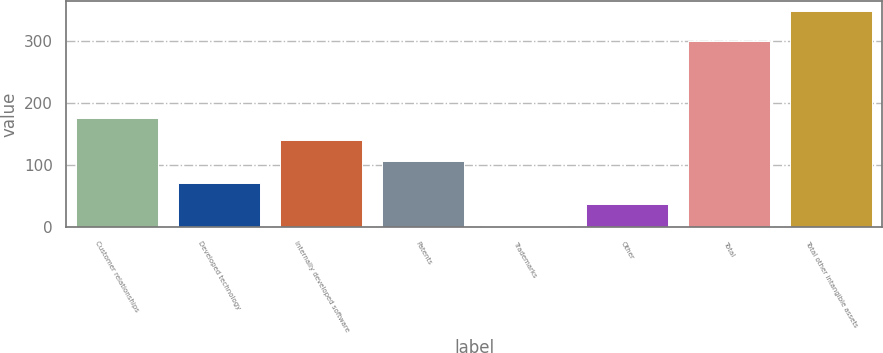Convert chart to OTSL. <chart><loc_0><loc_0><loc_500><loc_500><bar_chart><fcel>Customer relationships<fcel>Developed technology<fcel>Internally developed software<fcel>Patents<fcel>Trademarks<fcel>Other<fcel>Total<fcel>Total other intangible assets<nl><fcel>175.4<fcel>71.72<fcel>140.84<fcel>106.28<fcel>2.6<fcel>37.16<fcel>299.7<fcel>348.2<nl></chart> 